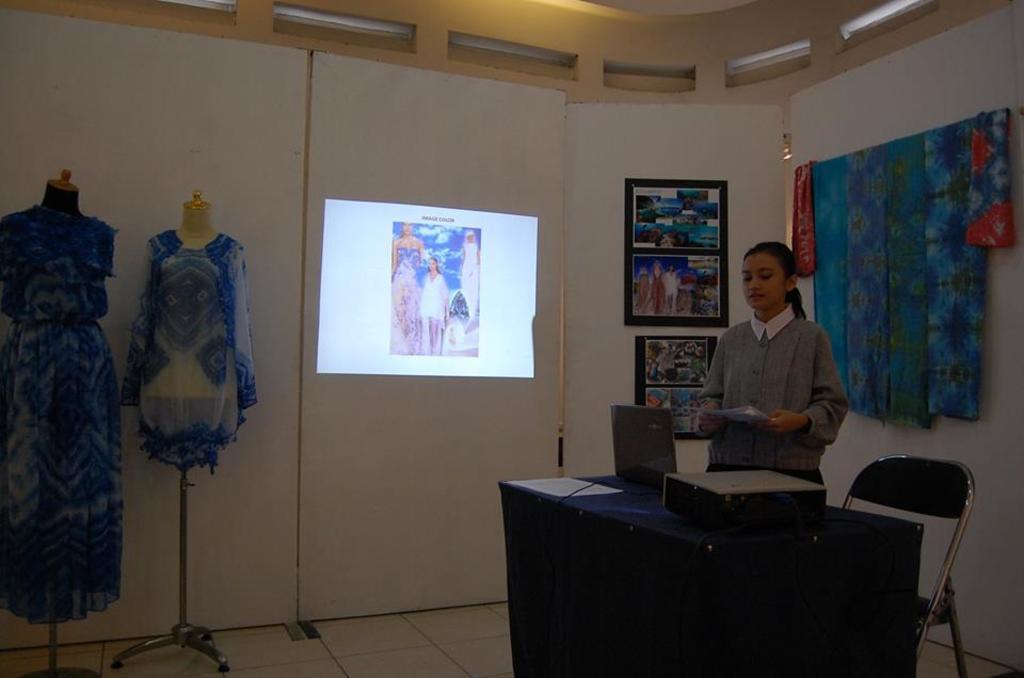In one or two sentences, can you explain what this image depicts? We can able to see a screen on wall. On wall there are different type of photos. These are clothes. This woman is standing and holding a paper. In-front of this woman there is a table, on a table there is a device and laptop. This is chair. 